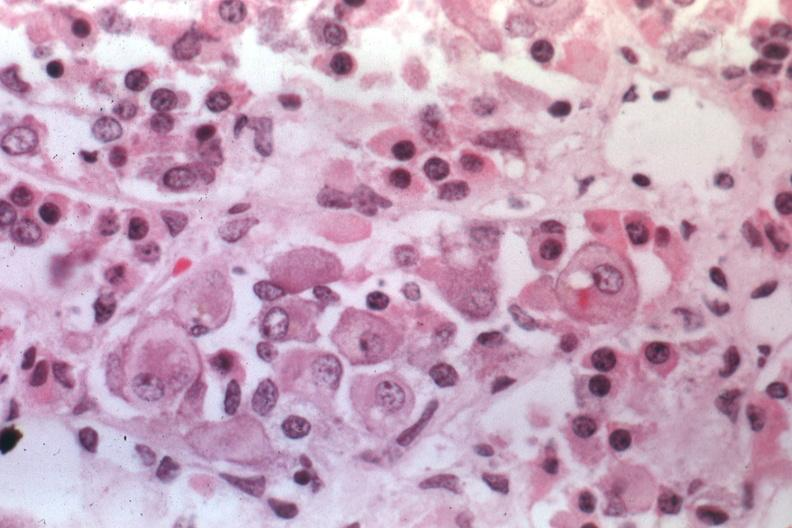what is present?
Answer the question using a single word or phrase. Crookes cells 